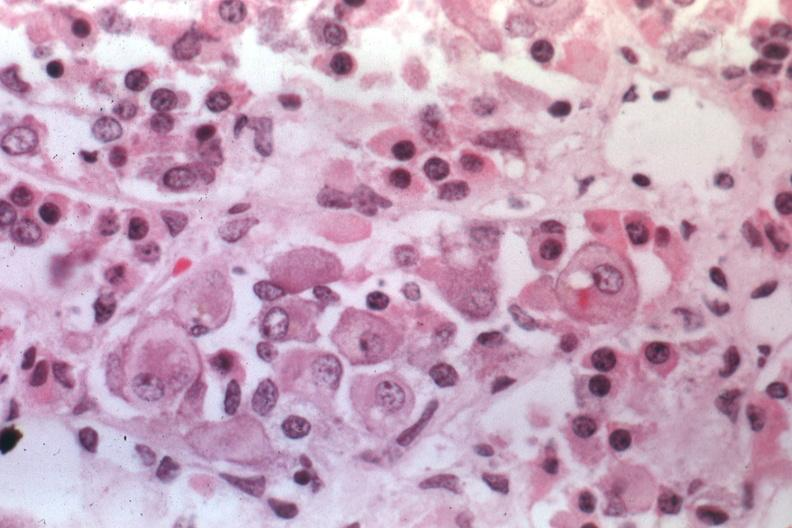what is present?
Answer the question using a single word or phrase. Crookes cells 